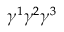Convert formula to latex. <formula><loc_0><loc_0><loc_500><loc_500>\gamma ^ { 1 } \gamma ^ { 2 } \gamma ^ { 3 }</formula> 